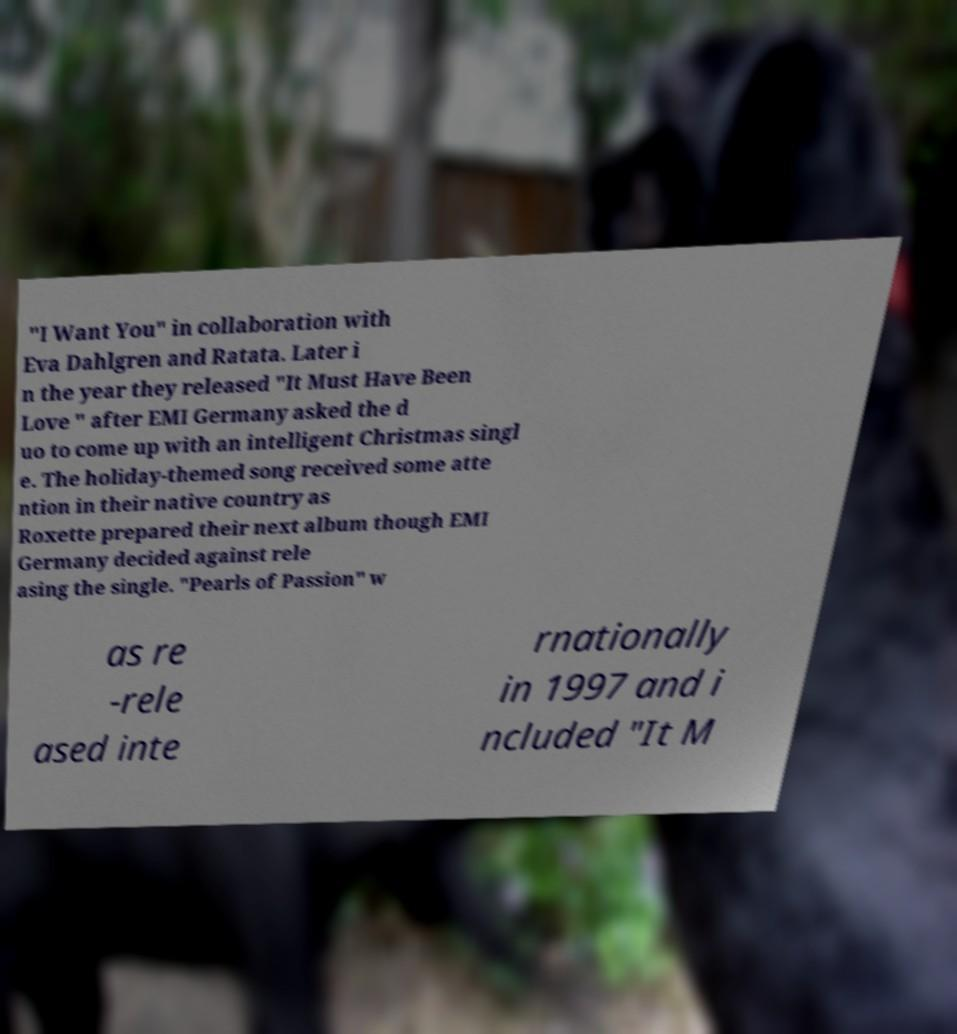What messages or text are displayed in this image? I need them in a readable, typed format. "I Want You" in collaboration with Eva Dahlgren and Ratata. Later i n the year they released "It Must Have Been Love " after EMI Germany asked the d uo to come up with an intelligent Christmas singl e. The holiday-themed song received some atte ntion in their native country as Roxette prepared their next album though EMI Germany decided against rele asing the single. "Pearls of Passion" w as re -rele ased inte rnationally in 1997 and i ncluded "It M 